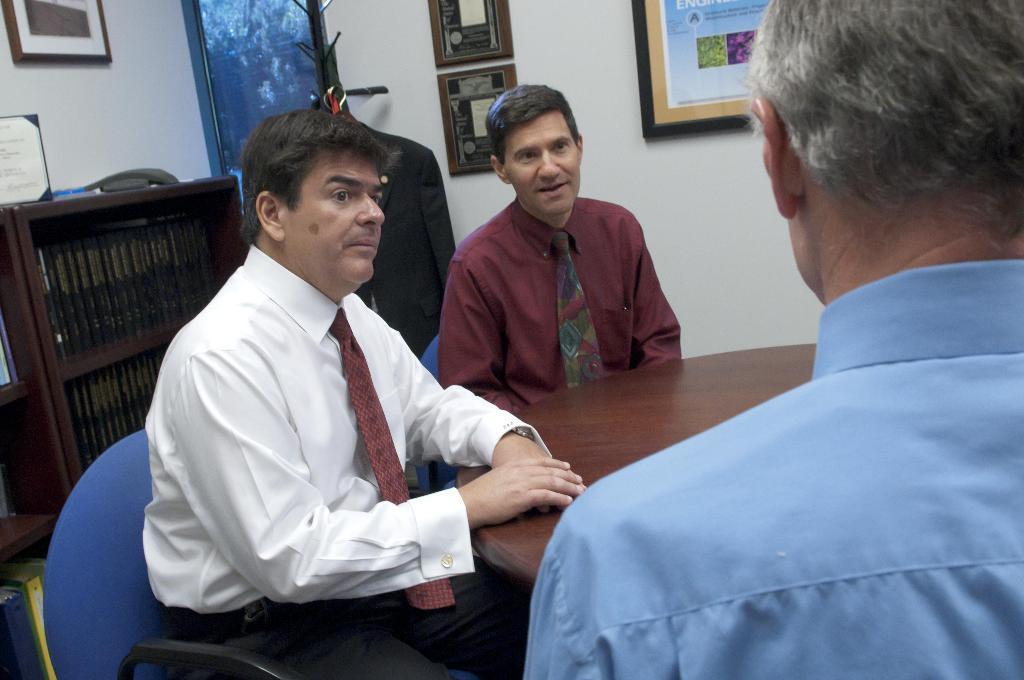Please provide a concise description of this image. In this picture I can see few people are sitting on the chairs in front of the table, around there are some frames to the wall. 